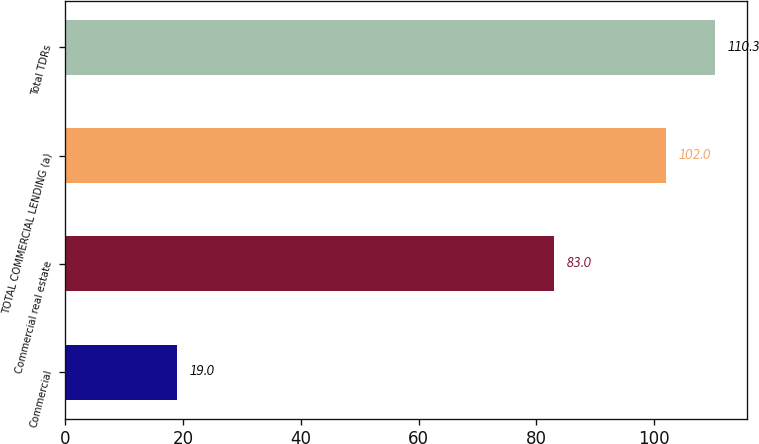<chart> <loc_0><loc_0><loc_500><loc_500><bar_chart><fcel>Commercial<fcel>Commercial real estate<fcel>TOTAL COMMERCIAL LENDING (a)<fcel>Total TDRs<nl><fcel>19<fcel>83<fcel>102<fcel>110.3<nl></chart> 